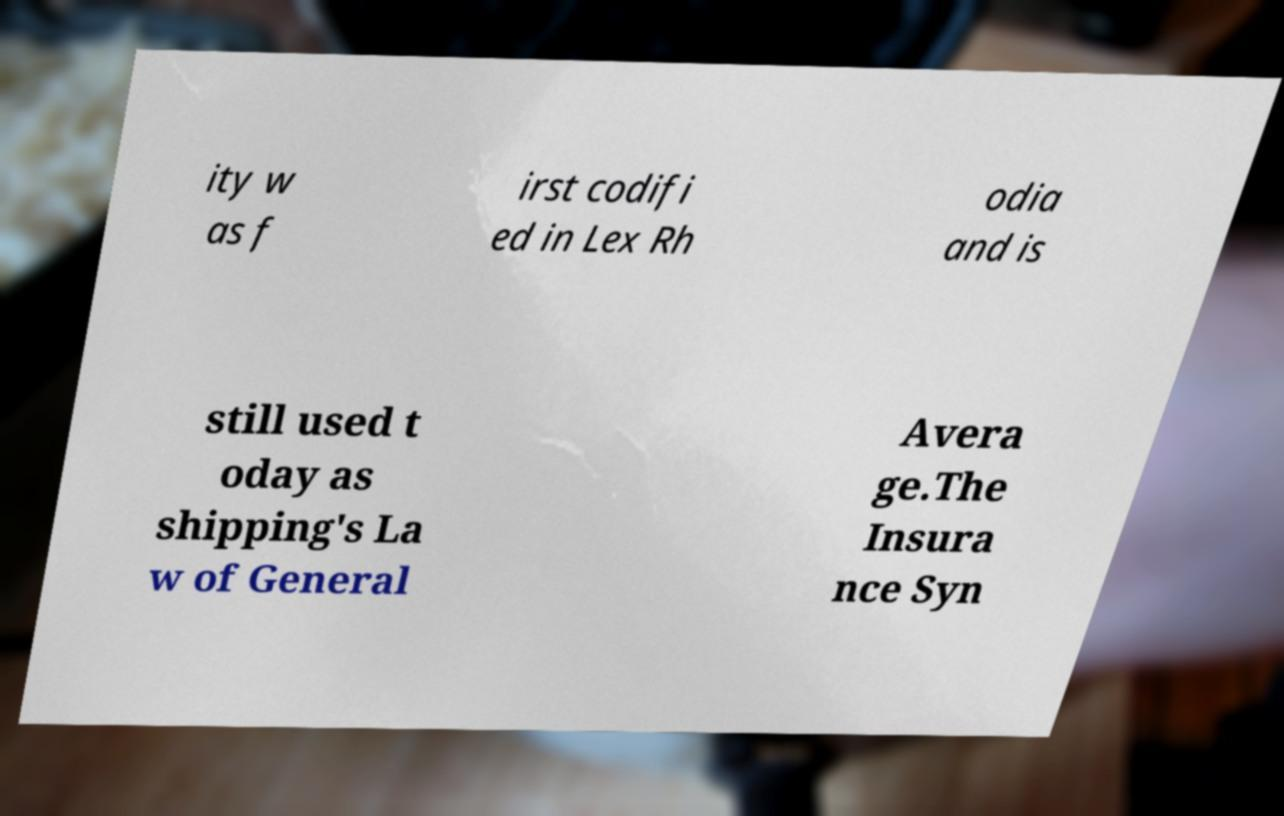Please read and relay the text visible in this image. What does it say? ity w as f irst codifi ed in Lex Rh odia and is still used t oday as shipping's La w of General Avera ge.The Insura nce Syn 